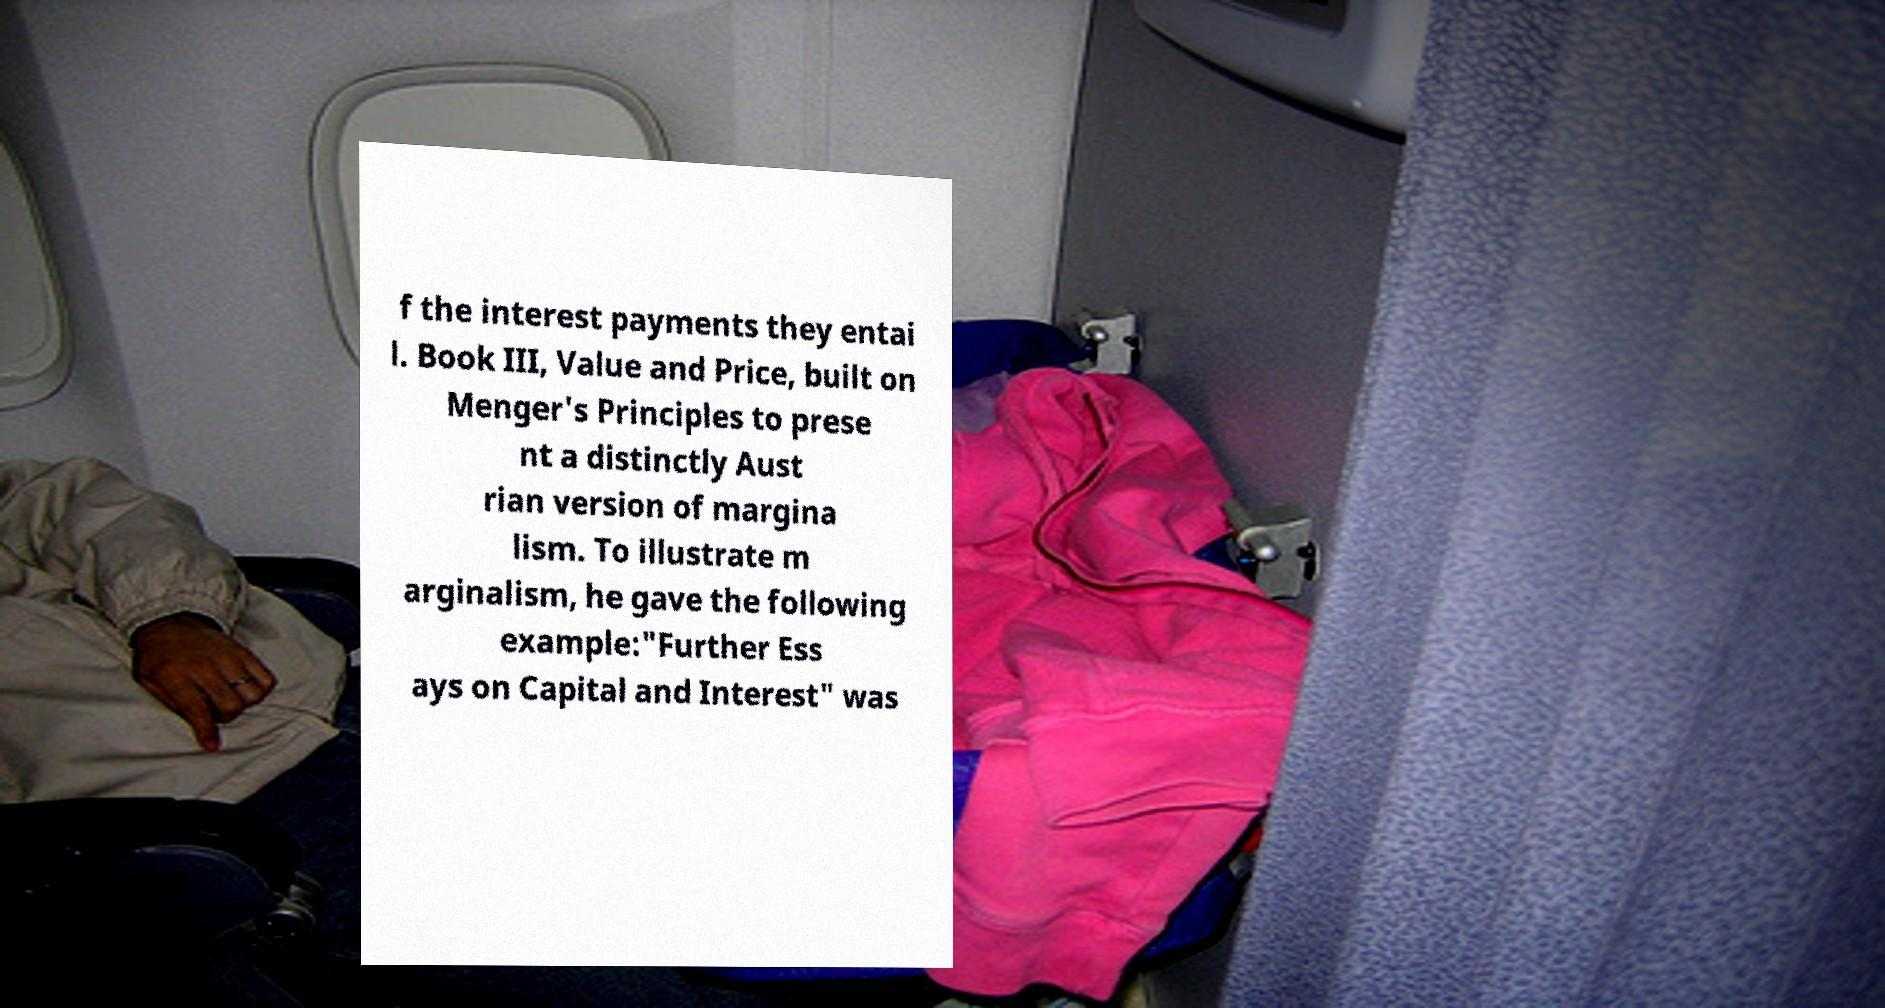I need the written content from this picture converted into text. Can you do that? f the interest payments they entai l. Book III, Value and Price, built on Menger's Principles to prese nt a distinctly Aust rian version of margina lism. To illustrate m arginalism, he gave the following example:"Further Ess ays on Capital and Interest" was 